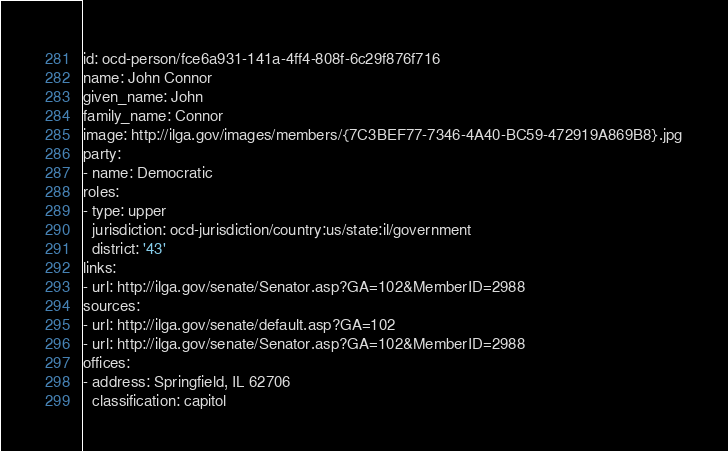<code> <loc_0><loc_0><loc_500><loc_500><_YAML_>id: ocd-person/fce6a931-141a-4ff4-808f-6c29f876f716
name: John Connor
given_name: John
family_name: Connor
image: http://ilga.gov/images/members/{7C3BEF77-7346-4A40-BC59-472919A869B8}.jpg
party:
- name: Democratic
roles:
- type: upper
  jurisdiction: ocd-jurisdiction/country:us/state:il/government
  district: '43'
links:
- url: http://ilga.gov/senate/Senator.asp?GA=102&MemberID=2988
sources:
- url: http://ilga.gov/senate/default.asp?GA=102
- url: http://ilga.gov/senate/Senator.asp?GA=102&MemberID=2988
offices:
- address: Springfield, IL 62706
  classification: capitol
</code> 